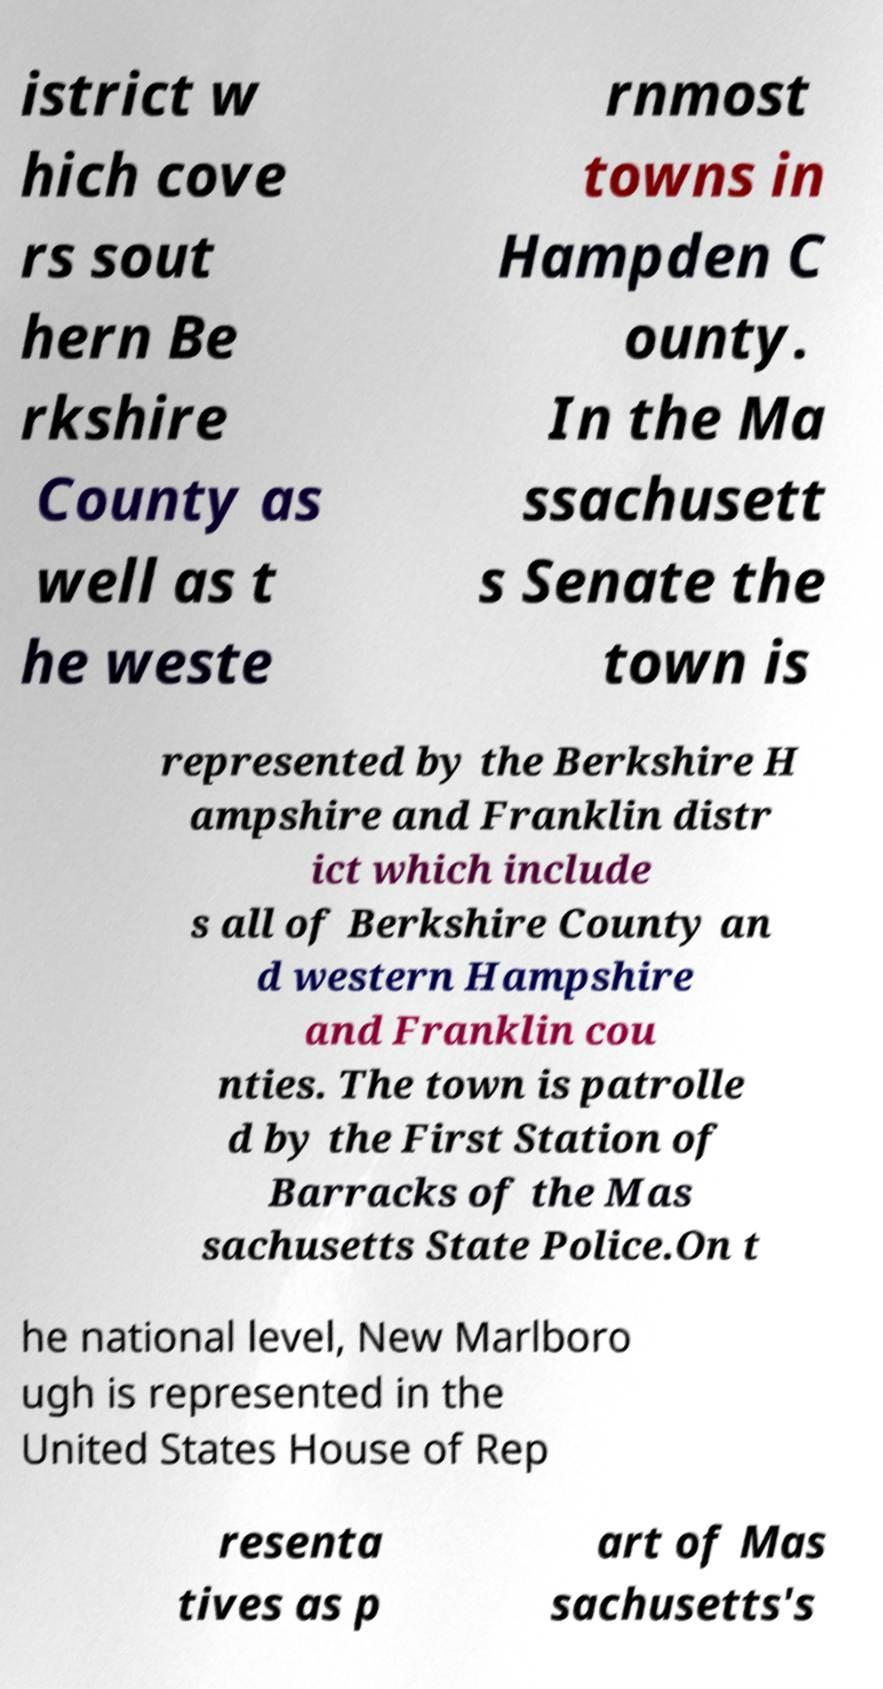Please read and relay the text visible in this image. What does it say? istrict w hich cove rs sout hern Be rkshire County as well as t he weste rnmost towns in Hampden C ounty. In the Ma ssachusett s Senate the town is represented by the Berkshire H ampshire and Franklin distr ict which include s all of Berkshire County an d western Hampshire and Franklin cou nties. The town is patrolle d by the First Station of Barracks of the Mas sachusetts State Police.On t he national level, New Marlboro ugh is represented in the United States House of Rep resenta tives as p art of Mas sachusetts's 